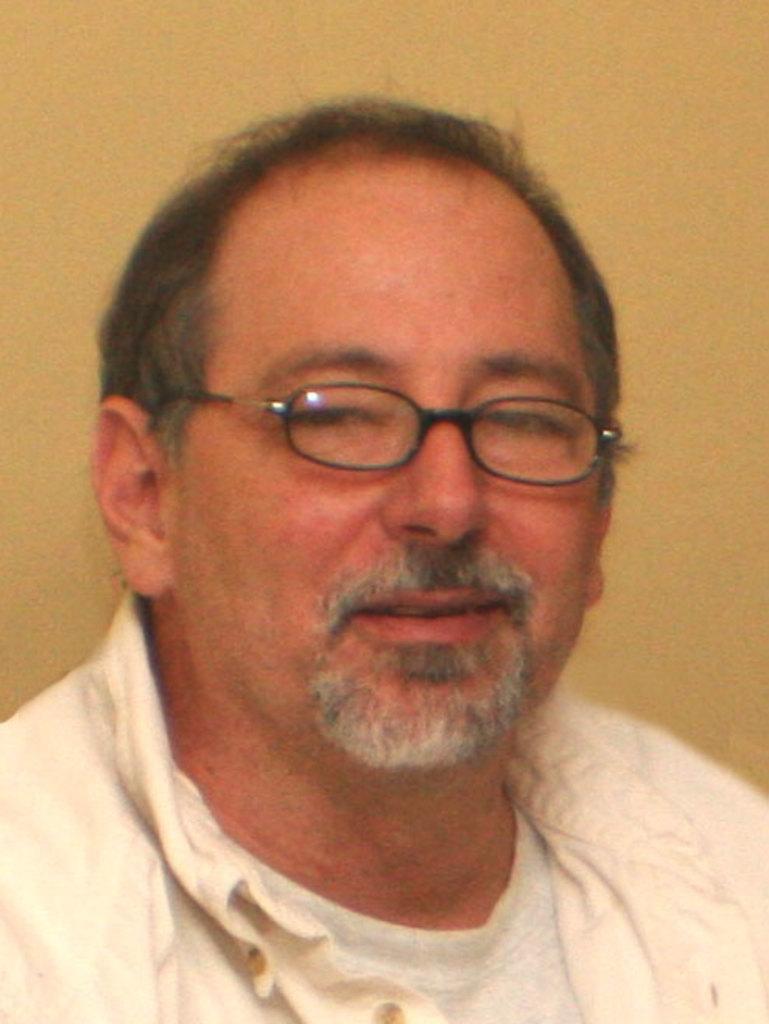Can you describe this image briefly? There is a man in the picture. This man is having a bald head. He is wearing a spectacles. And he is having a smile in his face. This man is also having a french cut beard style. This man is wearing a shirt and a T shirt inside the shirt. 